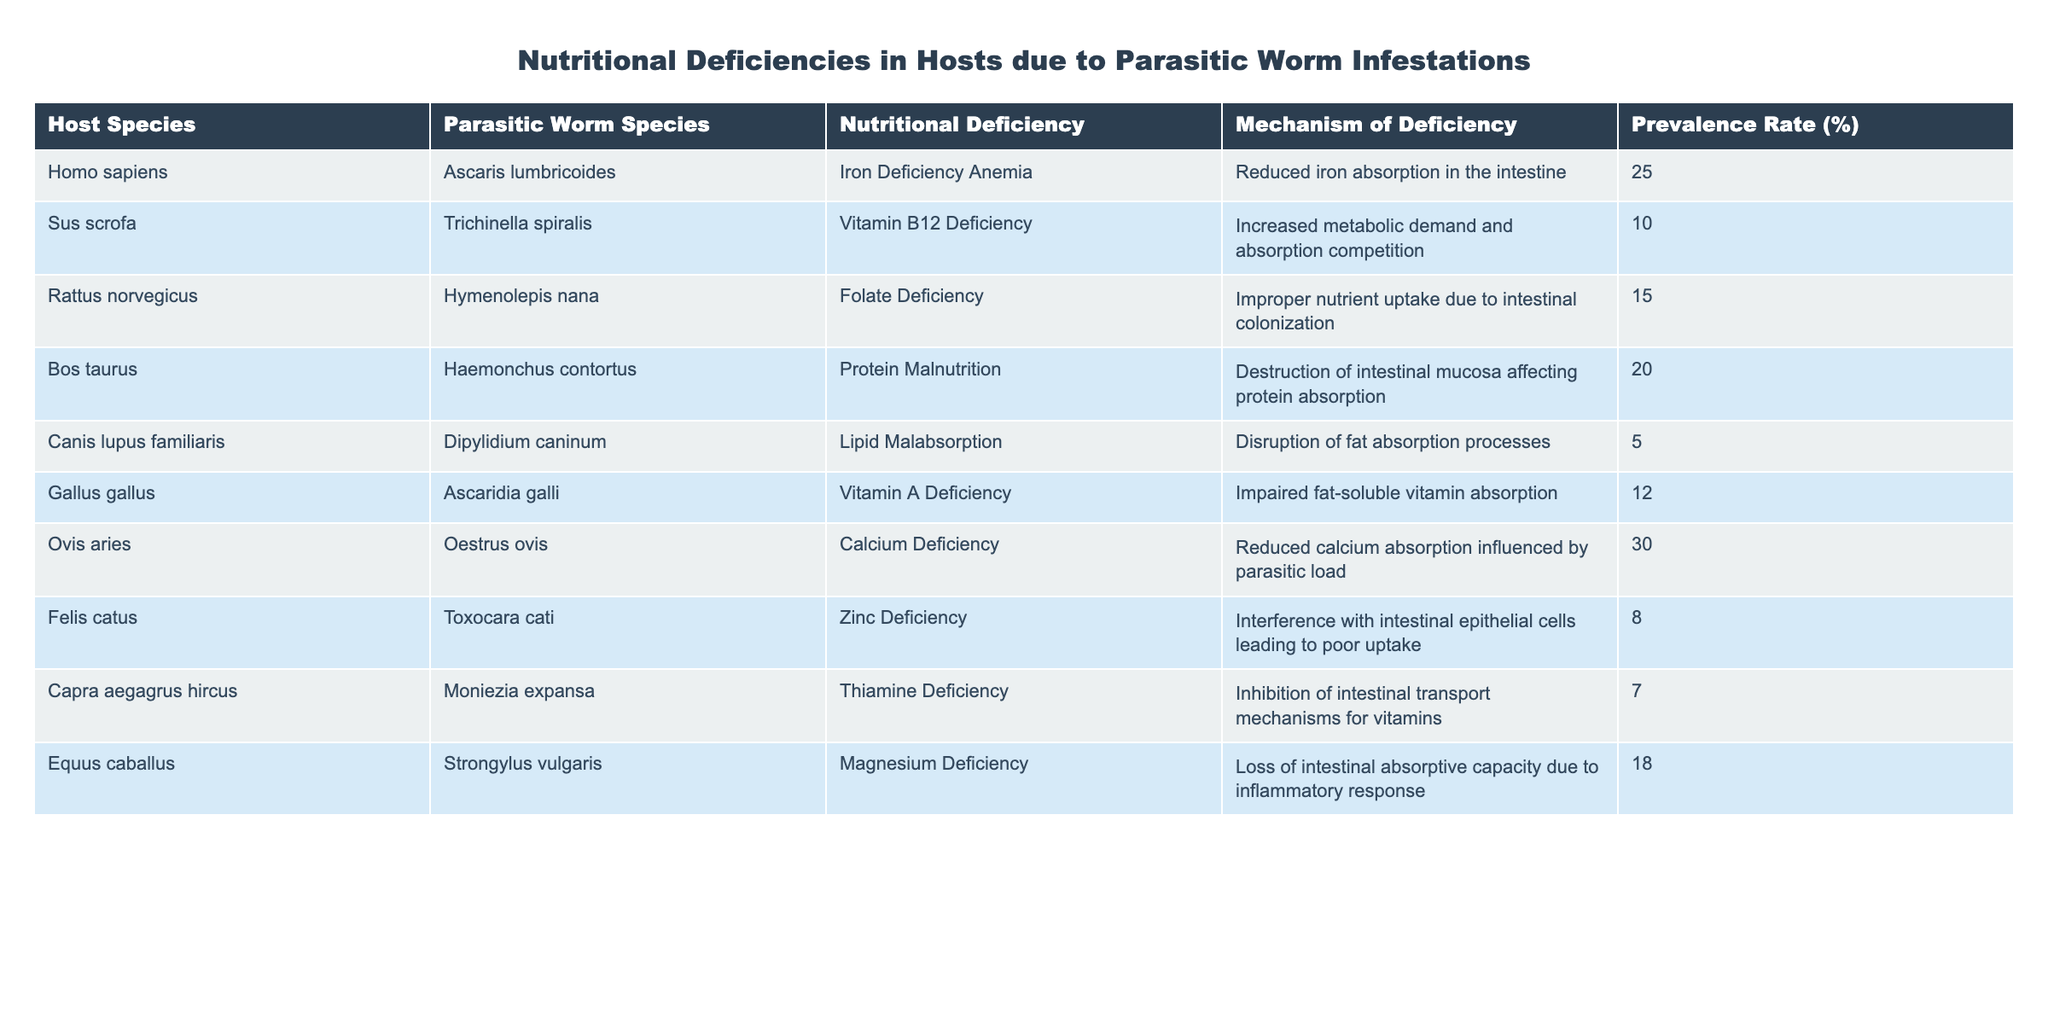What is the prevalence rate of Iron Deficiency Anemia in Homo sapiens? The table lists a prevalence rate of 25% for Iron Deficiency Anemia in Homo sapiens. This is directly observed from the relevant row in the table.
Answer: 25% Which parasitic worm species is associated with Vitamin B12 Deficiency in Sus scrofa? The parasitic worm species associated with Vitamin B12 Deficiency in Sus scrofa is Trichinella spiralis, as indicated in the table under the respective columns.
Answer: Trichinella spiralis What is the average prevalence rate of nutritional deficiencies reported in the table? To calculate the average prevalence rate, sum all the prevalence rates (25 + 10 + 15 + 20 + 5 + 12 + 30 + 8 + 7 + 18 =  250) and divide by the number of hosts (10). The average prevalence rate is thus 250/10 = 25.
Answer: 25% Are there any hosts with Zinc Deficiency, and if so, what is the prevalence rate? Yes, there is one host listed with Zinc Deficiency, which is Felis catus, and the prevalence rate is 8%, as found in the table.
Answer: Yes, 8% Which nutritional deficiency has the highest reported prevalence rate among the hosts? By examining the prevalence rates in the table, Ovis aries has the highest reported prevalence rate of Calcium Deficiency at 30%, which is the highest of all entries.
Answer: Calcium Deficiency, 30% What is the difference in prevalence rates between Protein Malnutrition in Bos taurus and Folate Deficiency in Rattus norvegicus? Protein Malnutrition in Bos taurus has a prevalence rate of 20%, while Folate Deficiency in Rattus norvegicus has a prevalence rate of 15%. The difference is calculated as 20 - 15 = 5%.
Answer: 5% Which nutritional deficiencies are associated with hosts from the order Carnivora? The table shows that the only host from the order Carnivora listed is Canis lupus familiaris, which exhibits Lipid Malabsorption, and Felis catus, which shows Zinc Deficiency. Hence, the associated deficiencies are Lipid Malabsorption and Zinc Deficiency.
Answer: Lipid Malabsorption, Zinc Deficiency 